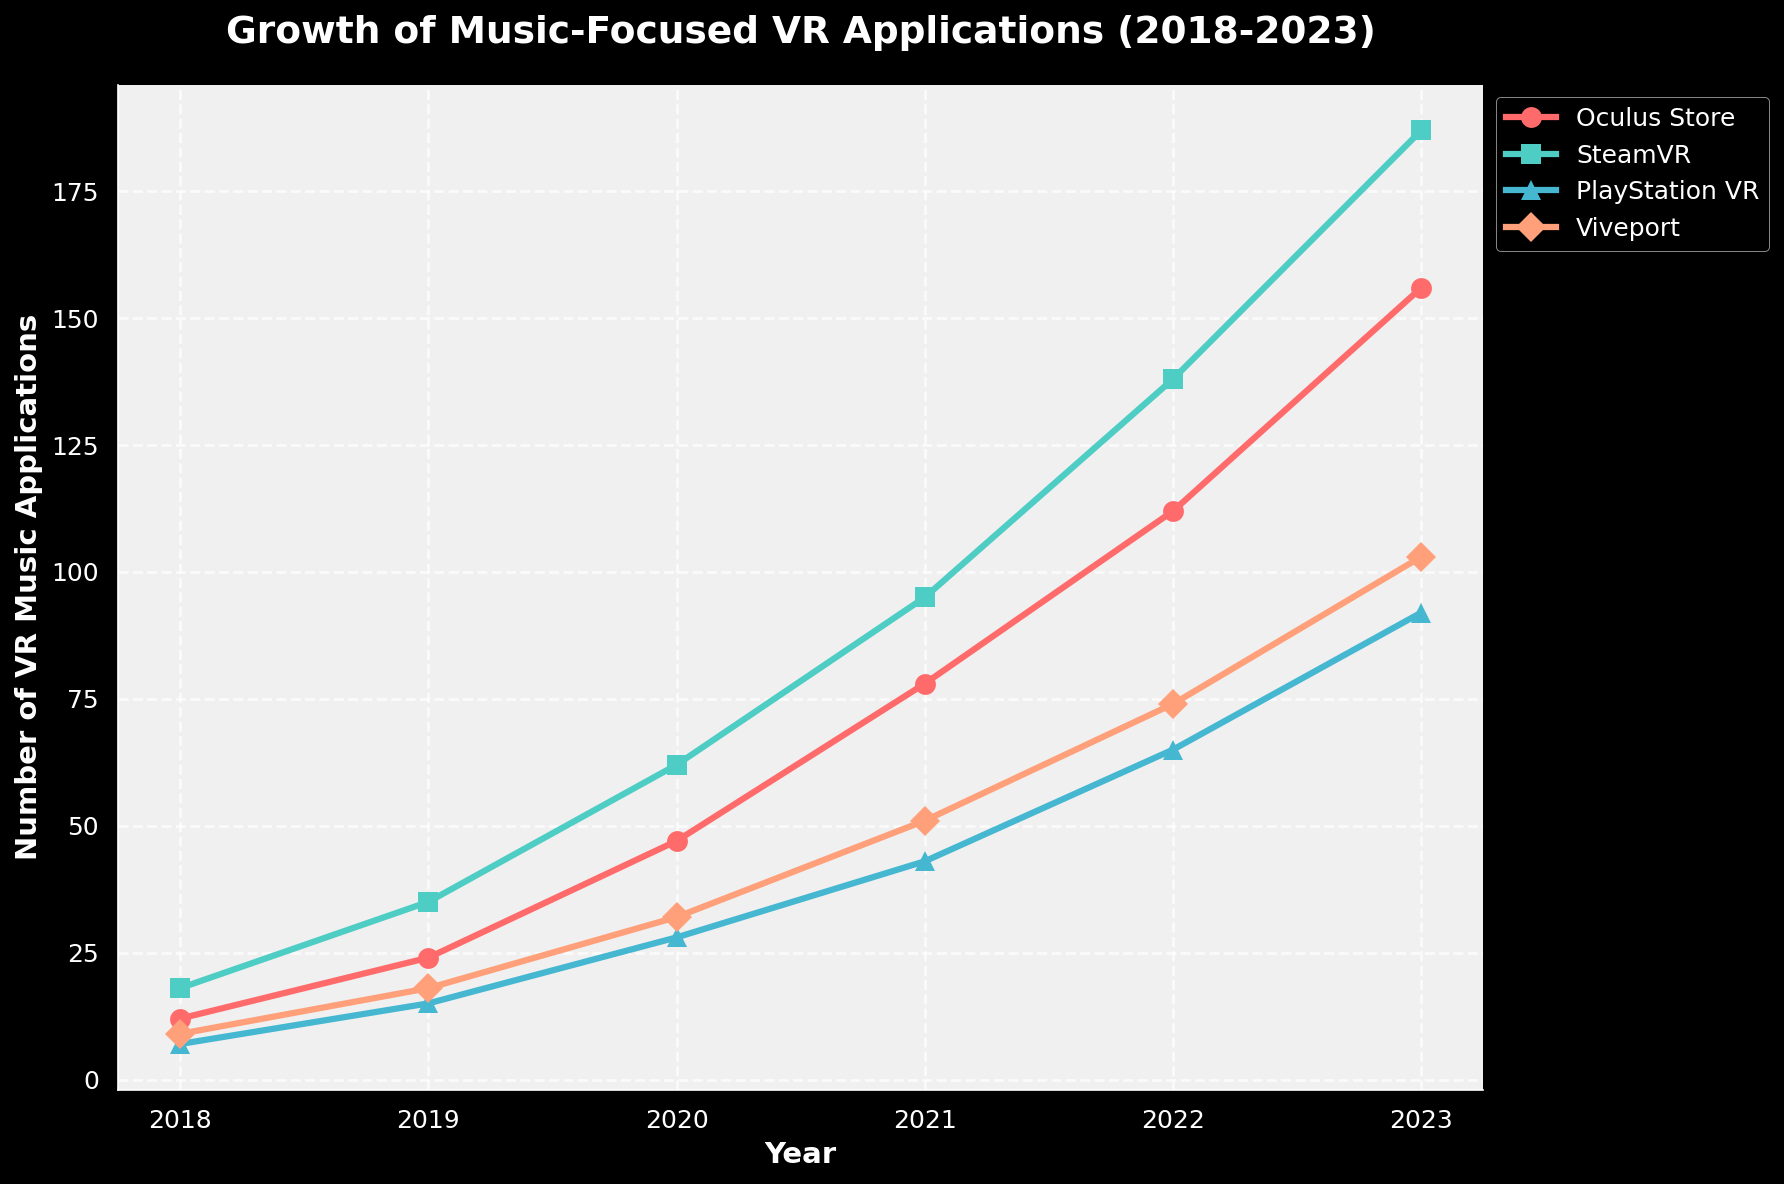What year saw the largest increase in the number of VR music applications on the Oculus Store? To find the year with the largest increase, calculate the differences between consecutive years for the Oculus Store data, and find the maximum. From 2018-2019: 12, 2019-2020: 23, 2020-2021: 31, 2021-2022: 34, 2022-2023: 44. The largest increase is from 2022 to 2023.
Answer: 2022 to 2023 Which platform had the most significant growth from 2018 to 2023? To determine which platform had the most growth, subtract the 2018 number from the 2023 number for each platform and compare. Oculus Store: 156-12=144, SteamVR: 187-18=169, PlayStation VR: 92-7=85, Viveport: 103-9=94. SteamVR has the most growth.
Answer: SteamVR How many platforms had more than 50 VR music applications by 2021? Check numbers in 2021 for all platforms: Oculus Store: 78, SteamVR: 95, PlayStation VR: 43, Viveport: 51. Three platforms (Oculus Store, SteamVR, Viveport) had more than 50 applications in 2021.
Answer: 3 Which platform showed the least increase in applications from 2020 to 2023? Compute the differences for each platform from 2020 to 2023. Oculus Store: 156-47=109, SteamVR: 187-62=125, PlayStation VR: 92-28=64, Viveport: 103-32=71. PlayStation VR had the least increase with 64.
Answer: PlayStation VR Was there any year when Viveport had fewer applications than PlayStation VR? Compare the numbers for Viveport and PlayStation VR for each year. Yearly figures show Viveport consistently higher (9 vs. 7 in 2018 to 103 vs. 92 in 2023). No year had fewer applications in Viveport.
Answer: No Which platform had exactly double the number of applications in 2020 compared to 2018? Double the 2018 numbers: Oculus Store: 24, SteamVR: 36, PlayStation VR: 14, Viveport: 18. Compare with 2020 figures: Oculus Store had 47, SteamVR had 62, PlayStation VR had 28, Viveport had 32. None had exactly double.
Answer: None From 2019 to 2020, which platform had the highest percentage increase? Calculate percentage increase: Oculus Store: (47-24)/24*100 = 95.83%, SteamVR: (62-35)/35*100 = 77.14%, PlayStation VR: (28-15)/15*100 = 86.67%, Viveport: (32-18)/18*100 = 77.78%. Oculus Store had the highest increase.
Answer: Oculus Store 